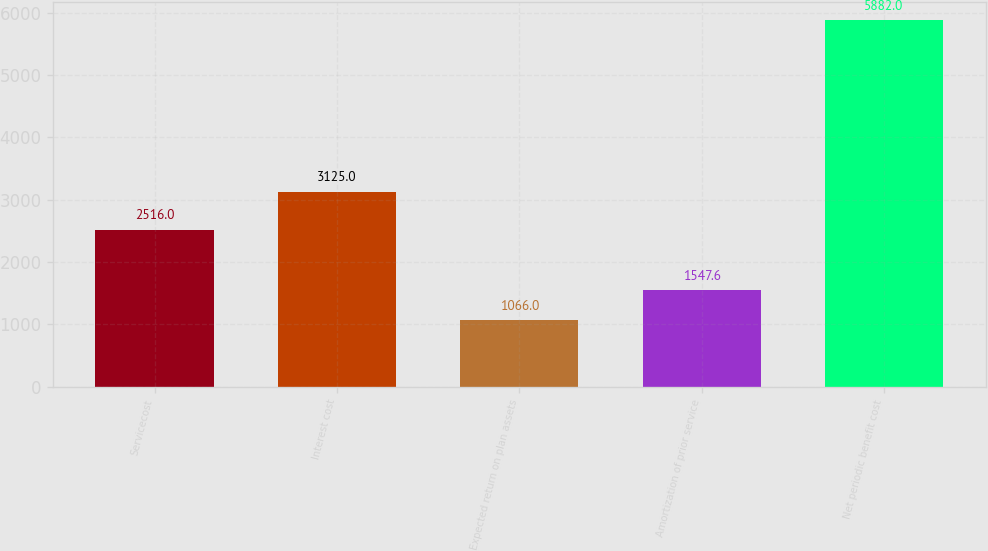Convert chart. <chart><loc_0><loc_0><loc_500><loc_500><bar_chart><fcel>Servicecost<fcel>Interest cost<fcel>Expected return on plan assets<fcel>Amortization of prior service<fcel>Net periodic benefit cost<nl><fcel>2516<fcel>3125<fcel>1066<fcel>1547.6<fcel>5882<nl></chart> 